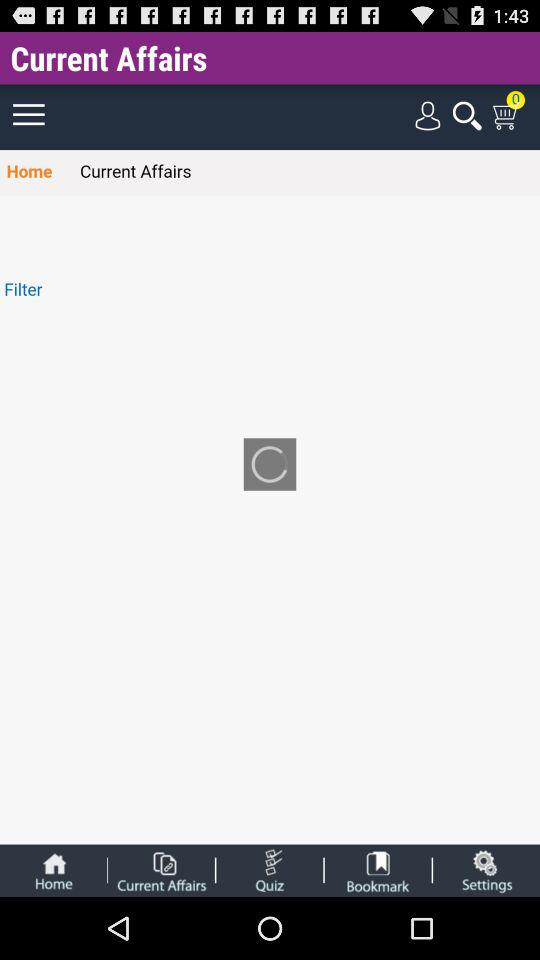How many items are there in the cart? There are 0 items in the cart. 